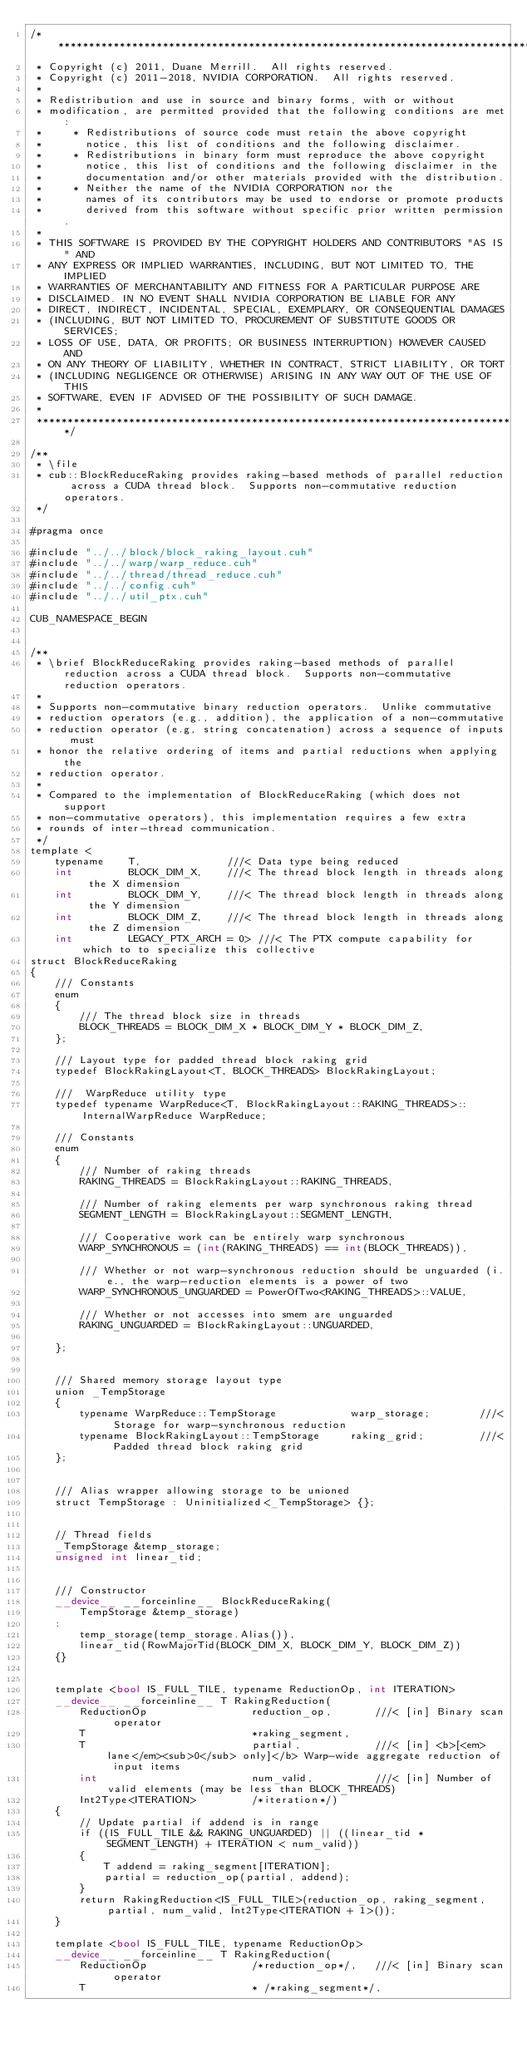Convert code to text. <code><loc_0><loc_0><loc_500><loc_500><_Cuda_>/******************************************************************************
 * Copyright (c) 2011, Duane Merrill.  All rights reserved.
 * Copyright (c) 2011-2018, NVIDIA CORPORATION.  All rights reserved.
 * 
 * Redistribution and use in source and binary forms, with or without
 * modification, are permitted provided that the following conditions are met:
 *     * Redistributions of source code must retain the above copyright
 *       notice, this list of conditions and the following disclaimer.
 *     * Redistributions in binary form must reproduce the above copyright
 *       notice, this list of conditions and the following disclaimer in the
 *       documentation and/or other materials provided with the distribution.
 *     * Neither the name of the NVIDIA CORPORATION nor the
 *       names of its contributors may be used to endorse or promote products
 *       derived from this software without specific prior written permission.
 * 
 * THIS SOFTWARE IS PROVIDED BY THE COPYRIGHT HOLDERS AND CONTRIBUTORS "AS IS" AND
 * ANY EXPRESS OR IMPLIED WARRANTIES, INCLUDING, BUT NOT LIMITED TO, THE IMPLIED
 * WARRANTIES OF MERCHANTABILITY AND FITNESS FOR A PARTICULAR PURPOSE ARE
 * DISCLAIMED. IN NO EVENT SHALL NVIDIA CORPORATION BE LIABLE FOR ANY
 * DIRECT, INDIRECT, INCIDENTAL, SPECIAL, EXEMPLARY, OR CONSEQUENTIAL DAMAGES
 * (INCLUDING, BUT NOT LIMITED TO, PROCUREMENT OF SUBSTITUTE GOODS OR SERVICES;
 * LOSS OF USE, DATA, OR PROFITS; OR BUSINESS INTERRUPTION) HOWEVER CAUSED AND
 * ON ANY THEORY OF LIABILITY, WHETHER IN CONTRACT, STRICT LIABILITY, OR TORT
 * (INCLUDING NEGLIGENCE OR OTHERWISE) ARISING IN ANY WAY OUT OF THE USE OF THIS
 * SOFTWARE, EVEN IF ADVISED OF THE POSSIBILITY OF SUCH DAMAGE.
 *
 ******************************************************************************/

/**
 * \file
 * cub::BlockReduceRaking provides raking-based methods of parallel reduction across a CUDA thread block.  Supports non-commutative reduction operators.
 */

#pragma once

#include "../../block/block_raking_layout.cuh"
#include "../../warp/warp_reduce.cuh"
#include "../../thread/thread_reduce.cuh"
#include "../../config.cuh"
#include "../../util_ptx.cuh"

CUB_NAMESPACE_BEGIN


/**
 * \brief BlockReduceRaking provides raking-based methods of parallel reduction across a CUDA thread block.  Supports non-commutative reduction operators.
 *
 * Supports non-commutative binary reduction operators.  Unlike commutative
 * reduction operators (e.g., addition), the application of a non-commutative
 * reduction operator (e.g, string concatenation) across a sequence of inputs must
 * honor the relative ordering of items and partial reductions when applying the
 * reduction operator.
 *
 * Compared to the implementation of BlockReduceRaking (which does not support
 * non-commutative operators), this implementation requires a few extra
 * rounds of inter-thread communication.
 */
template <
    typename    T,              ///< Data type being reduced
    int         BLOCK_DIM_X,    ///< The thread block length in threads along the X dimension
    int         BLOCK_DIM_Y,    ///< The thread block length in threads along the Y dimension
    int         BLOCK_DIM_Z,    ///< The thread block length in threads along the Z dimension
    int         LEGACY_PTX_ARCH = 0> ///< The PTX compute capability for which to to specialize this collective
struct BlockReduceRaking
{
    /// Constants
    enum
    {
        /// The thread block size in threads
        BLOCK_THREADS = BLOCK_DIM_X * BLOCK_DIM_Y * BLOCK_DIM_Z,
    };

    /// Layout type for padded thread block raking grid
    typedef BlockRakingLayout<T, BLOCK_THREADS> BlockRakingLayout;

    ///  WarpReduce utility type
    typedef typename WarpReduce<T, BlockRakingLayout::RAKING_THREADS>::InternalWarpReduce WarpReduce;

    /// Constants
    enum
    {
        /// Number of raking threads
        RAKING_THREADS = BlockRakingLayout::RAKING_THREADS,

        /// Number of raking elements per warp synchronous raking thread
        SEGMENT_LENGTH = BlockRakingLayout::SEGMENT_LENGTH,

        /// Cooperative work can be entirely warp synchronous
        WARP_SYNCHRONOUS = (int(RAKING_THREADS) == int(BLOCK_THREADS)),

        /// Whether or not warp-synchronous reduction should be unguarded (i.e., the warp-reduction elements is a power of two
        WARP_SYNCHRONOUS_UNGUARDED = PowerOfTwo<RAKING_THREADS>::VALUE,

        /// Whether or not accesses into smem are unguarded
        RAKING_UNGUARDED = BlockRakingLayout::UNGUARDED,

    };


    /// Shared memory storage layout type
    union _TempStorage
    {
        typename WarpReduce::TempStorage            warp_storage;        ///< Storage for warp-synchronous reduction
        typename BlockRakingLayout::TempStorage     raking_grid;         ///< Padded thread block raking grid
    };


    /// Alias wrapper allowing storage to be unioned
    struct TempStorage : Uninitialized<_TempStorage> {};


    // Thread fields
    _TempStorage &temp_storage;
    unsigned int linear_tid;


    /// Constructor
    __device__ __forceinline__ BlockReduceRaking(
        TempStorage &temp_storage)
    :
        temp_storage(temp_storage.Alias()),
        linear_tid(RowMajorTid(BLOCK_DIM_X, BLOCK_DIM_Y, BLOCK_DIM_Z))
    {}


    template <bool IS_FULL_TILE, typename ReductionOp, int ITERATION>
    __device__ __forceinline__ T RakingReduction(
        ReductionOp                 reduction_op,       ///< [in] Binary scan operator
        T                           *raking_segment,
        T                           partial,            ///< [in] <b>[<em>lane</em><sub>0</sub> only]</b> Warp-wide aggregate reduction of input items
        int                         num_valid,          ///< [in] Number of valid elements (may be less than BLOCK_THREADS)
        Int2Type<ITERATION>         /*iteration*/)
    {
        // Update partial if addend is in range
        if ((IS_FULL_TILE && RAKING_UNGUARDED) || ((linear_tid * SEGMENT_LENGTH) + ITERATION < num_valid))
        {
            T addend = raking_segment[ITERATION];
            partial = reduction_op(partial, addend);
        }
        return RakingReduction<IS_FULL_TILE>(reduction_op, raking_segment, partial, num_valid, Int2Type<ITERATION + 1>());
    }

    template <bool IS_FULL_TILE, typename ReductionOp>
    __device__ __forceinline__ T RakingReduction(
        ReductionOp                 /*reduction_op*/,   ///< [in] Binary scan operator
        T                           * /*raking_segment*/,</code> 